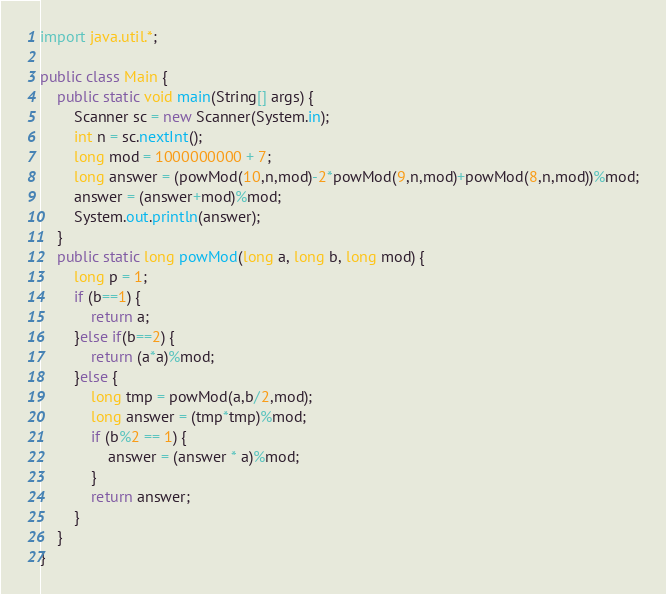<code> <loc_0><loc_0><loc_500><loc_500><_Java_>import java.util.*;

public class Main {
    public static void main(String[] args) {
        Scanner sc = new Scanner(System.in);
        int n = sc.nextInt();
        long mod = 1000000000 + 7;
        long answer = (powMod(10,n,mod)-2*powMod(9,n,mod)+powMod(8,n,mod))%mod;
        answer = (answer+mod)%mod;
        System.out.println(answer);
    }
    public static long powMod(long a, long b, long mod) {
        long p = 1;
        if (b==1) {
            return a;
        }else if(b==2) {
            return (a*a)%mod;
        }else {
            long tmp = powMod(a,b/2,mod);
            long answer = (tmp*tmp)%mod;
            if (b%2 == 1) {
                answer = (answer * a)%mod;
            }
            return answer;
        }
    }
}
</code> 